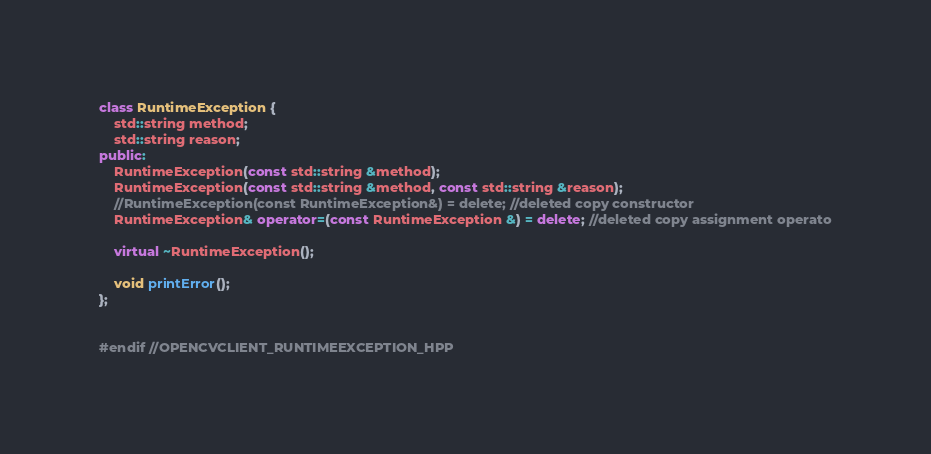Convert code to text. <code><loc_0><loc_0><loc_500><loc_500><_C++_>
class RuntimeException {
    std::string method;
    std::string reason;
public:
    RuntimeException(const std::string &method);
    RuntimeException(const std::string &method, const std::string &reason);
    //RuntimeException(const RuntimeException&) = delete; //deleted copy constructor
    RuntimeException& operator=(const RuntimeException &) = delete; //deleted copy assignment operato

    virtual ~RuntimeException();

    void printError();
};


#endif //OPENCVCLIENT_RUNTIMEEXCEPTION_HPP
</code> 